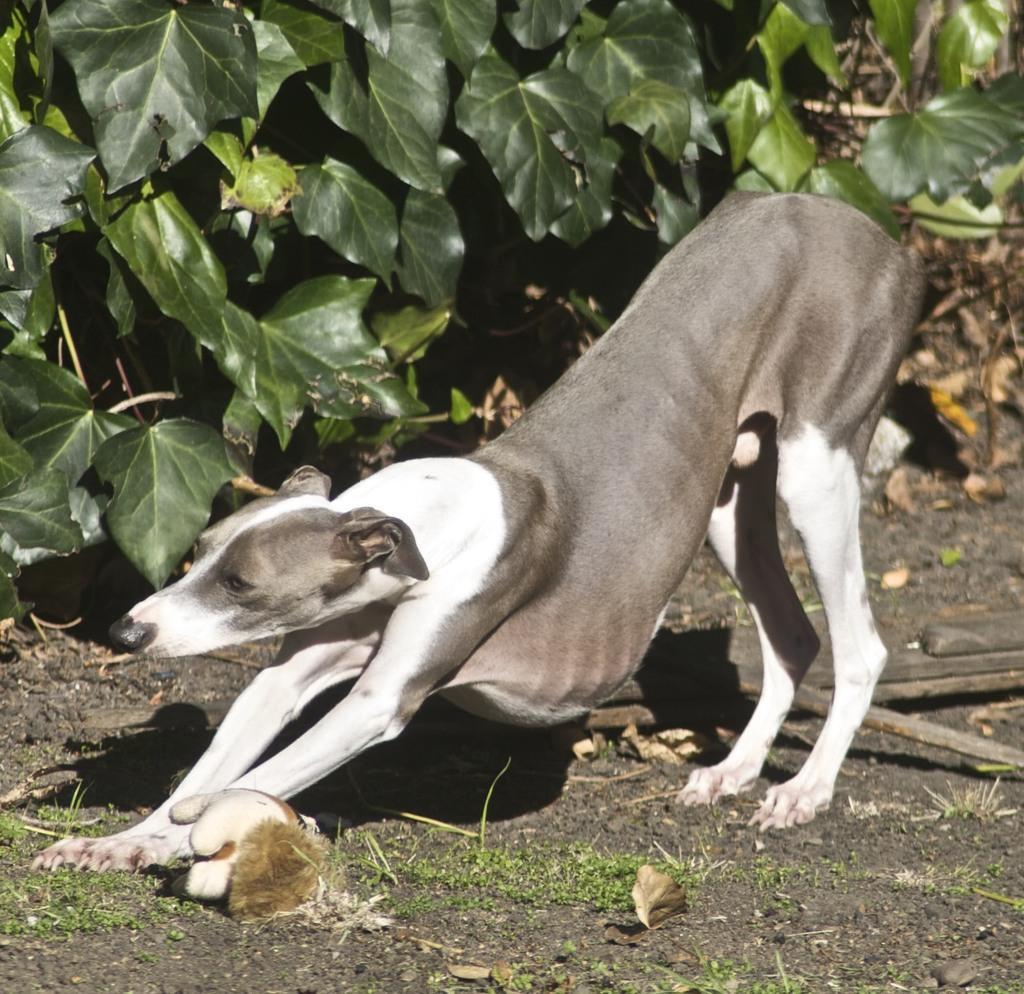How would you summarize this image in a sentence or two? In this picture we can see a dog, beside to the dog we can find few plants. 